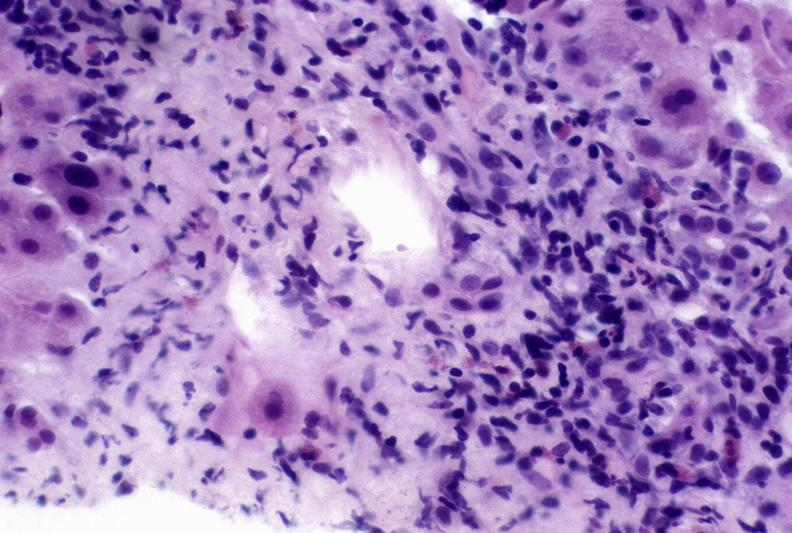s liver present?
Answer the question using a single word or phrase. Yes 